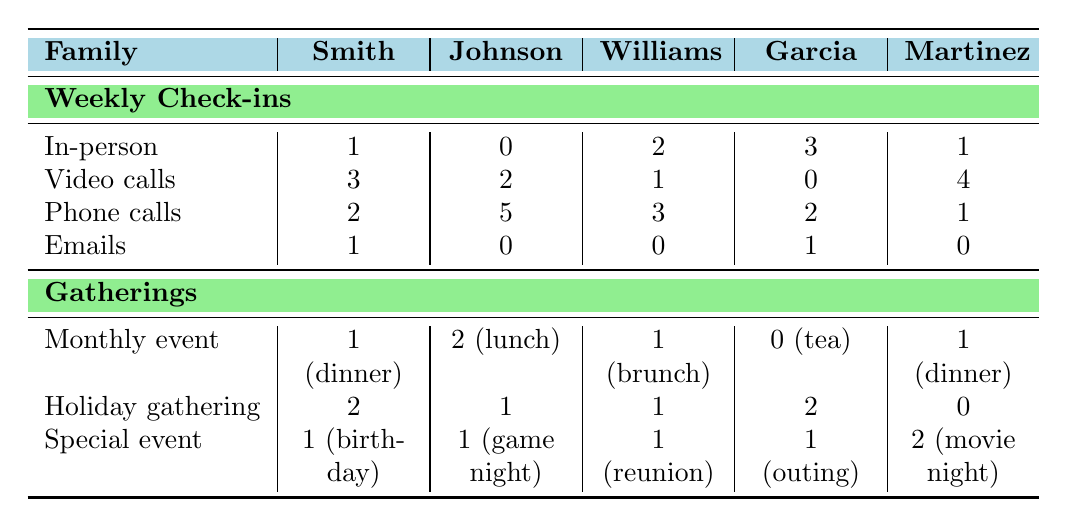What is the total number of weekly check-ins for the Johnson Family? To find the total weekly check-ins for the Johnson Family, we sum the values in each category under "weekly check-ins": 0 (in-person) + 2 (video calls) + 5 (phone calls) + 0 (emails) = 7.
Answer: 7 Which family has the highest number of phone calls during weekly check-ins? We look at the phone call numbers for each family: Smith (2), Johnson (5), Williams (3), Garcia (2), and Martinez (1). The highest number is from the Johnson Family with 5 phone calls.
Answer: Johnson Family How many total gatherings does the Garcia Family have? We sum the gatherings listed under "Gatherings" for the Garcia Family: 0 (monthly tea) + 2 (holiday gathering) + 1 (family outing) = 3.
Answer: 3 What is the average number of in-person check-ins across all families? We calculate the total in-person check-ins by summing the values: 1 (Smith) + 0 (Johnson) + 2 (Williams) + 3 (Garcia) + 1 (Martinez) = 7. There are 5 families, so the average is 7/5 = 1.4.
Answer: 1.4 Do the Williams Family have more video calls or phone calls during weekly check-ins? For the Williams Family, we see there are 1 video call and 3 phone calls. Since 3 is greater than 1, they have more phone calls.
Answer: Phone calls Which family has the least monthly gatherings? The Garcia Family has 0 monthly gatherings (0 for monthly tea), which is less than the other families.
Answer: Garcia Family How many more video calls does the Martinez Family have compared to the Smith Family? The Martinez Family has 4 video calls and the Smith Family has 3. To find the difference, we subtract: 4 - 3 = 1.
Answer: 1 What family has the most total gatherings? We calculate total gatherings for each family: Smith (1 + 2 + 1 = 4), Johnson (2 + 1 + 1 = 4), Williams (1 + 1 + 1 = 3), Garcia (0 + 2 + 1 = 3), Martinez (1 + 0 + 2 = 3). The Smith and Johnson Families tie with the most total gatherings at 4.
Answer: Smith and Johnson Families What percentage of the weekly check-ins for the Garcia Family are in-person? The Garcia Family has 6 total weekly check-ins (3 in-person + 0 video calls + 2 phone calls + 1 email). The in-person check-ins are 3, so the percentage is (3/6) * 100 = 50%.
Answer: 50% How many total family check-ins are conducted through emails for the Smith Family? The Smith Family has 1 email check-in listed.
Answer: 1 